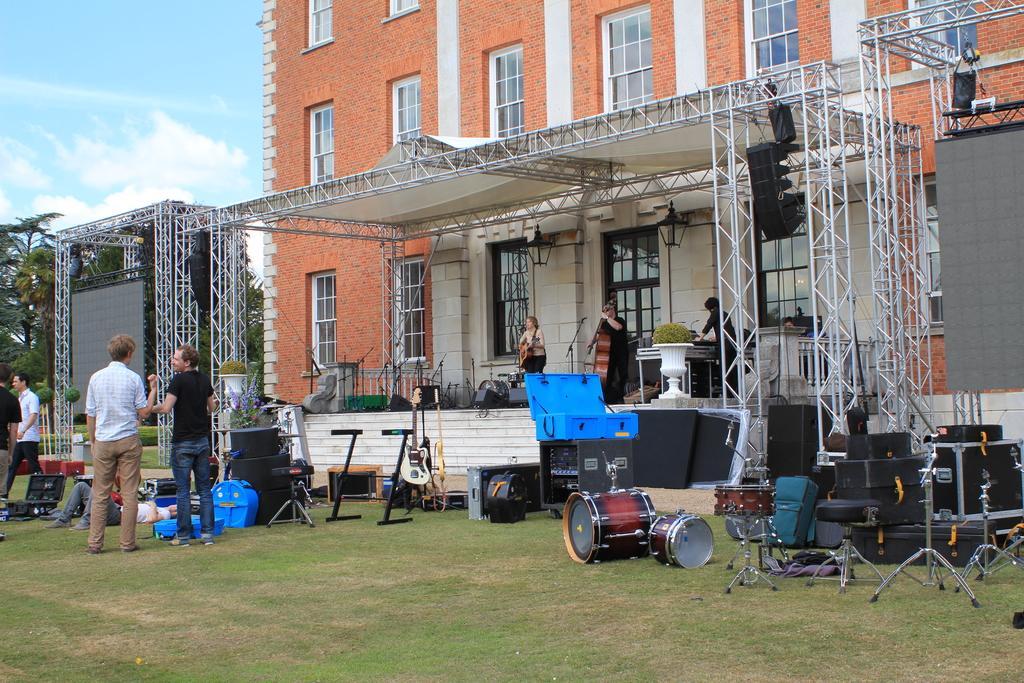Can you describe this image briefly? In this picture, we can see a few people on the ground and a few on the stage holding some musical instruments, and we can see some musical instruments on the ground, we can see the ground with grass, plants and trees, poles, and we can see the screen, and we can see building with windows, and the sky. 